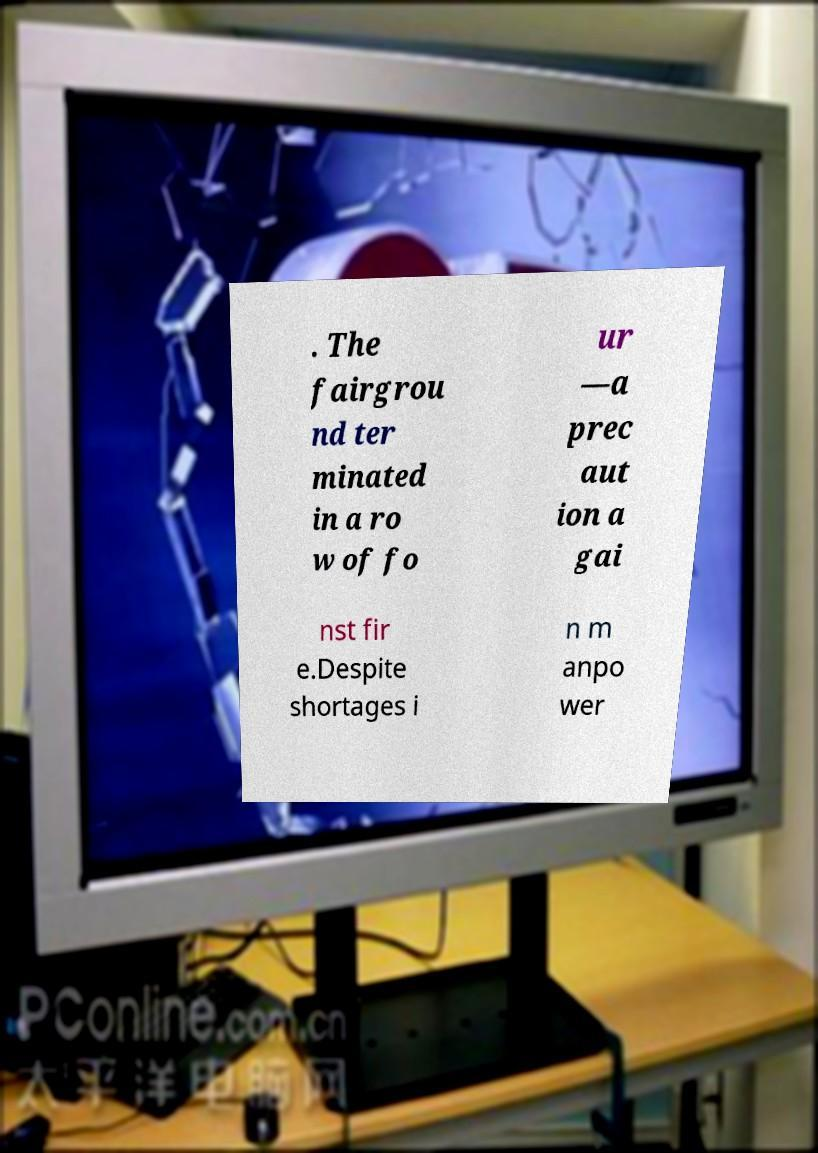I need the written content from this picture converted into text. Can you do that? . The fairgrou nd ter minated in a ro w of fo ur —a prec aut ion a gai nst fir e.Despite shortages i n m anpo wer 